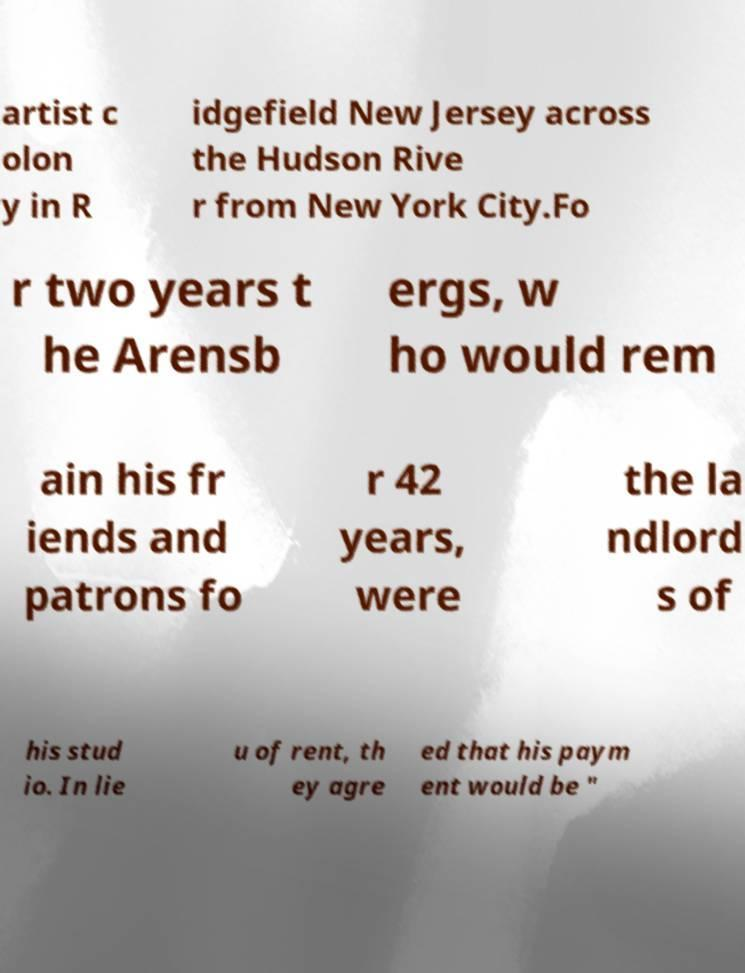Can you read and provide the text displayed in the image?This photo seems to have some interesting text. Can you extract and type it out for me? artist c olon y in R idgefield New Jersey across the Hudson Rive r from New York City.Fo r two years t he Arensb ergs, w ho would rem ain his fr iends and patrons fo r 42 years, were the la ndlord s of his stud io. In lie u of rent, th ey agre ed that his paym ent would be " 